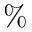Convert formula to latex. <formula><loc_0><loc_0><loc_500><loc_500>\%</formula> 